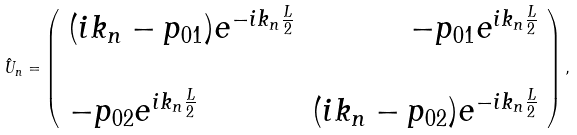Convert formula to latex. <formula><loc_0><loc_0><loc_500><loc_500>\hat { U } _ { n } = \left ( \begin{array} { l r } ( i k _ { n } - p _ { 0 1 } ) e ^ { - i k _ { n } \frac { L } { 2 } } & - p _ { 0 1 } e ^ { i k _ { n } \frac { L } { 2 } } \\ \ \\ - p _ { 0 2 } e ^ { i k _ { n } \frac { L } { 2 } } & ( i k _ { n } - p _ { 0 2 } ) e ^ { - i k _ { n } \frac { L } { 2 } } \\ \end{array} \right ) ,</formula> 